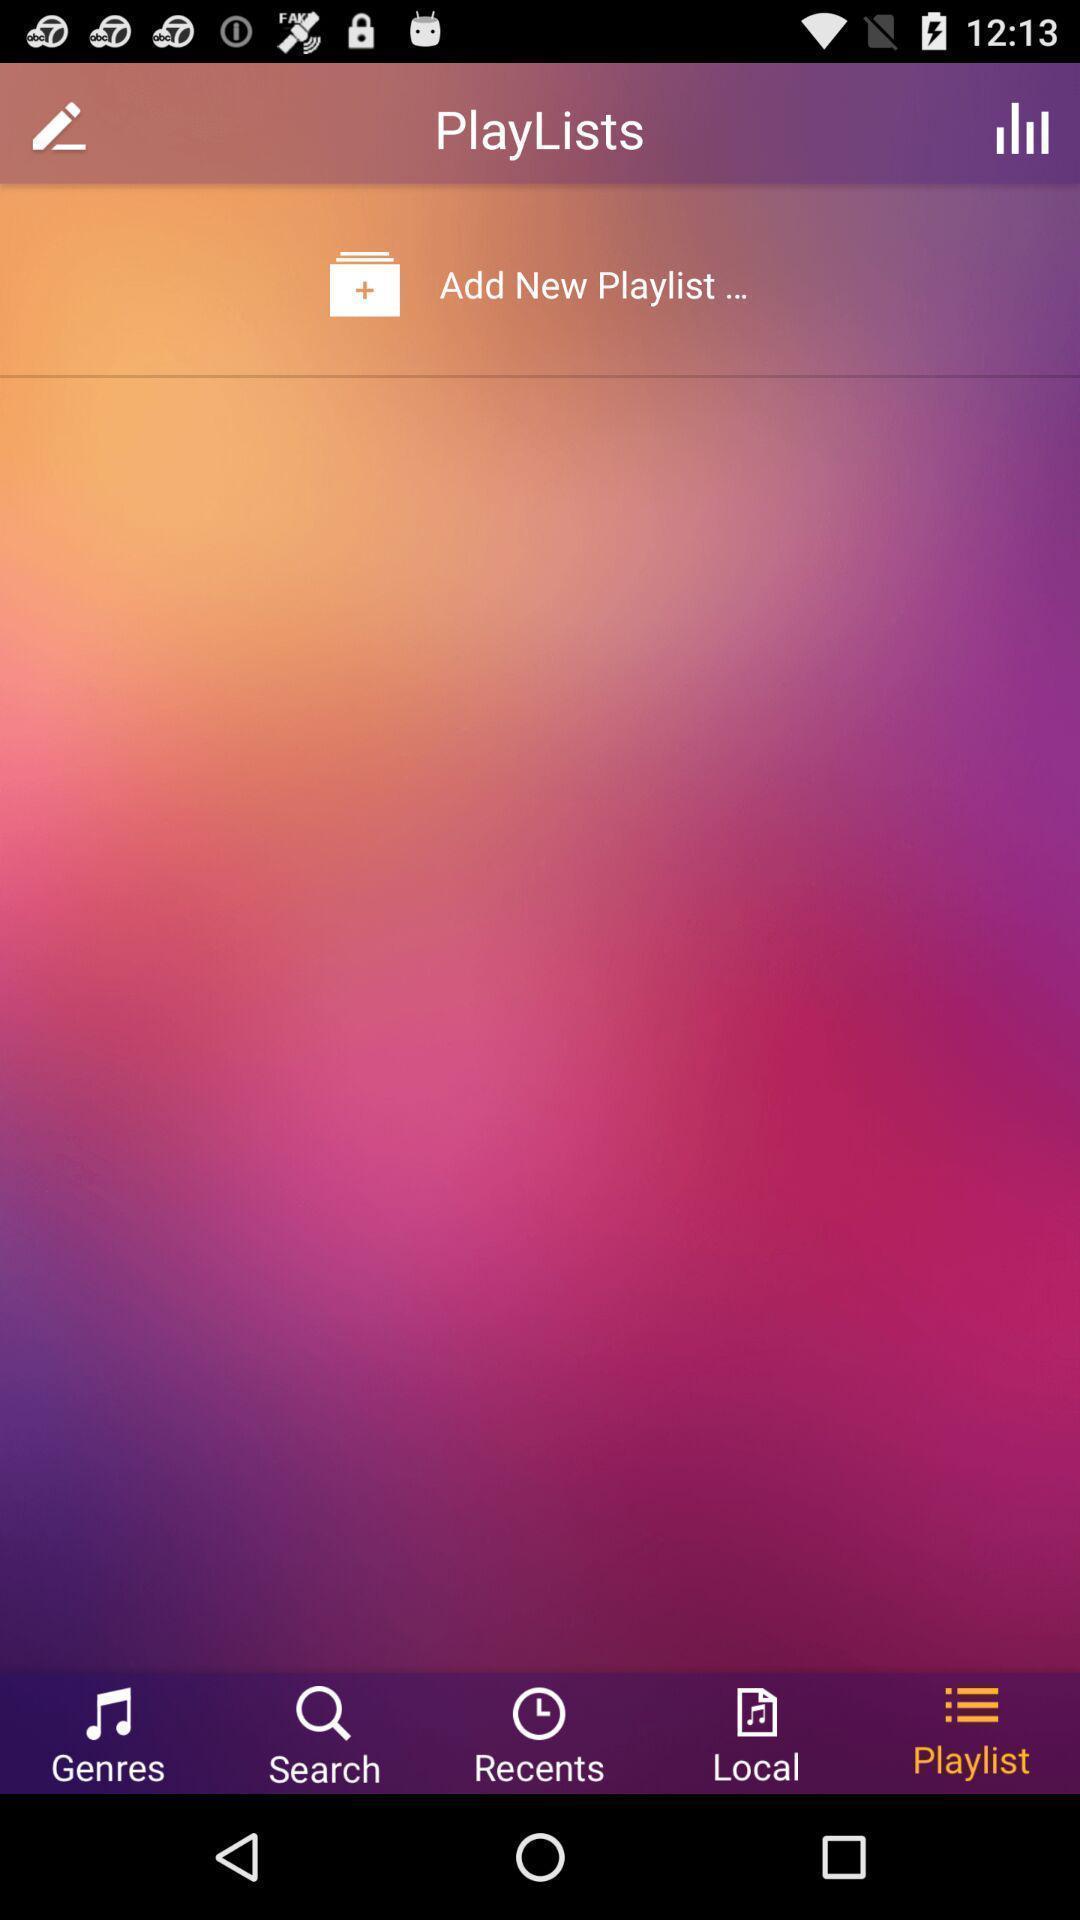Tell me about the visual elements in this screen capture. Screen asks to add new playlists. 